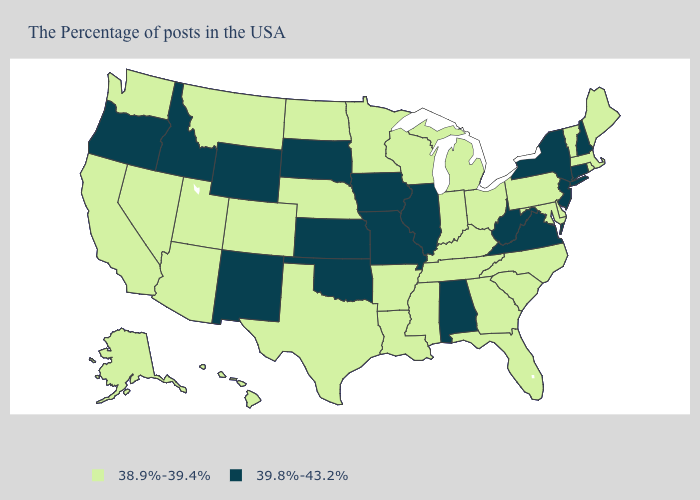Does Washington have the same value as Iowa?
Be succinct. No. What is the lowest value in the South?
Answer briefly. 38.9%-39.4%. What is the value of Louisiana?
Concise answer only. 38.9%-39.4%. Name the states that have a value in the range 39.8%-43.2%?
Give a very brief answer. New Hampshire, Connecticut, New York, New Jersey, Virginia, West Virginia, Alabama, Illinois, Missouri, Iowa, Kansas, Oklahoma, South Dakota, Wyoming, New Mexico, Idaho, Oregon. What is the value of Arkansas?
Write a very short answer. 38.9%-39.4%. What is the highest value in states that border Arizona?
Keep it brief. 39.8%-43.2%. Does Vermont have a higher value than Oregon?
Be succinct. No. Which states have the lowest value in the USA?
Write a very short answer. Maine, Massachusetts, Rhode Island, Vermont, Delaware, Maryland, Pennsylvania, North Carolina, South Carolina, Ohio, Florida, Georgia, Michigan, Kentucky, Indiana, Tennessee, Wisconsin, Mississippi, Louisiana, Arkansas, Minnesota, Nebraska, Texas, North Dakota, Colorado, Utah, Montana, Arizona, Nevada, California, Washington, Alaska, Hawaii. Which states hav the highest value in the South?
Answer briefly. Virginia, West Virginia, Alabama, Oklahoma. Among the states that border California , does Arizona have the highest value?
Write a very short answer. No. Does Connecticut have the same value as California?
Keep it brief. No. Is the legend a continuous bar?
Quick response, please. No. Does Arizona have a lower value than Texas?
Short answer required. No. What is the value of South Carolina?
Keep it brief. 38.9%-39.4%. Does the map have missing data?
Give a very brief answer. No. 